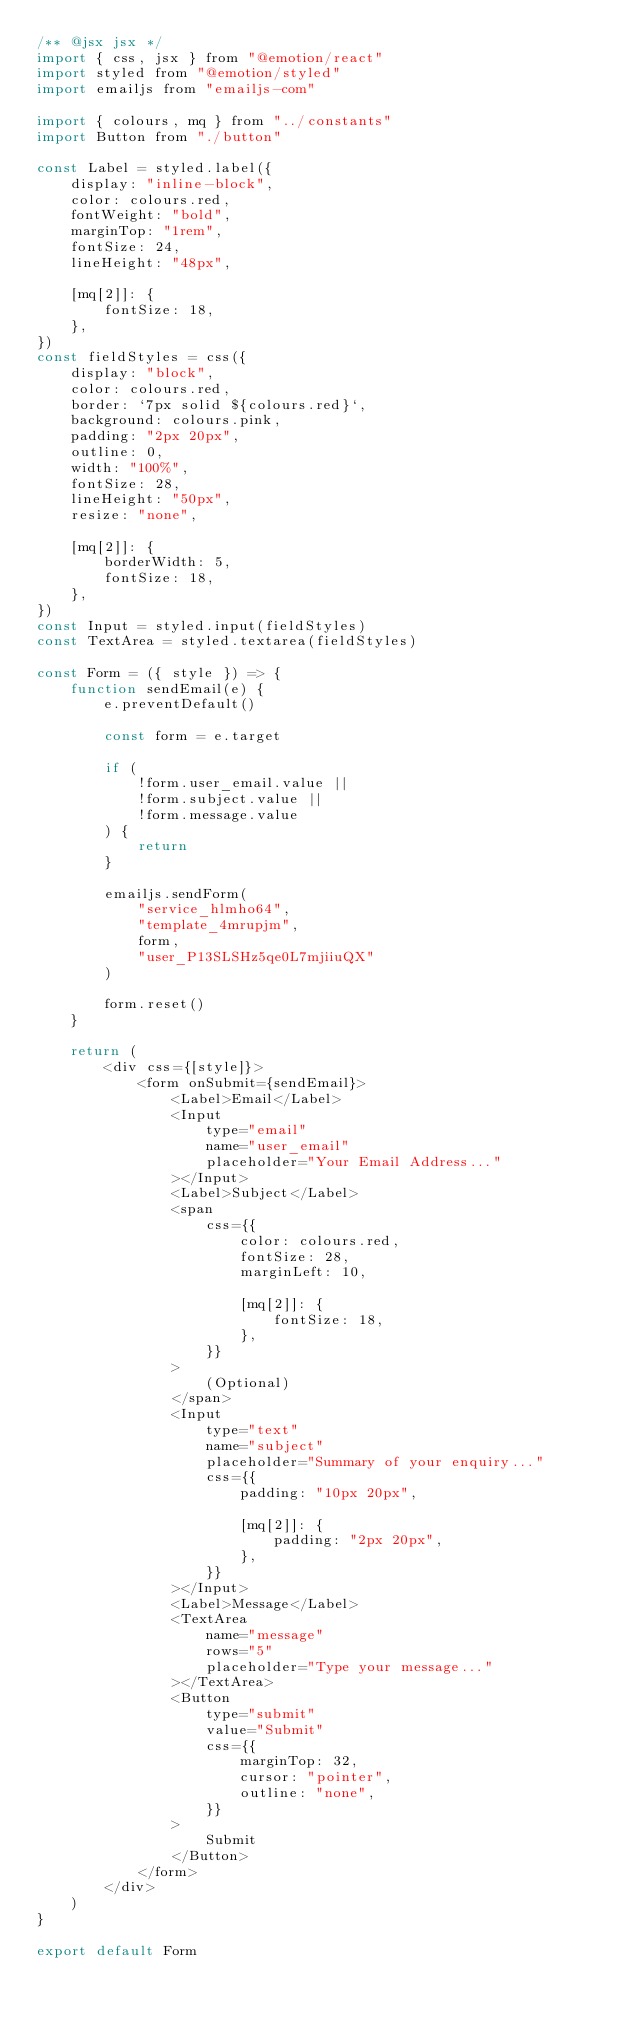<code> <loc_0><loc_0><loc_500><loc_500><_JavaScript_>/** @jsx jsx */
import { css, jsx } from "@emotion/react"
import styled from "@emotion/styled"
import emailjs from "emailjs-com"

import { colours, mq } from "../constants"
import Button from "./button"

const Label = styled.label({
    display: "inline-block",
    color: colours.red,
    fontWeight: "bold",
    marginTop: "1rem",
    fontSize: 24,
    lineHeight: "48px",

    [mq[2]]: {
        fontSize: 18,
    },
})
const fieldStyles = css({
    display: "block",
    color: colours.red,
    border: `7px solid ${colours.red}`,
    background: colours.pink,
    padding: "2px 20px",
    outline: 0,
    width: "100%",
    fontSize: 28,
    lineHeight: "50px",
    resize: "none",

    [mq[2]]: {
        borderWidth: 5,
        fontSize: 18,
    },
})
const Input = styled.input(fieldStyles)
const TextArea = styled.textarea(fieldStyles)

const Form = ({ style }) => {
    function sendEmail(e) {
        e.preventDefault()

        const form = e.target

        if (
            !form.user_email.value ||
            !form.subject.value ||
            !form.message.value
        ) {
            return
        }

        emailjs.sendForm(
            "service_hlmho64",
            "template_4mrupjm",
            form,
            "user_P13SLSHz5qe0L7mjiiuQX"
        )

        form.reset()
    }

    return (
        <div css={[style]}>
            <form onSubmit={sendEmail}>
                <Label>Email</Label>
                <Input
                    type="email"
                    name="user_email"
                    placeholder="Your Email Address..."
                ></Input>
                <Label>Subject</Label>
                <span
                    css={{
                        color: colours.red,
                        fontSize: 28,
                        marginLeft: 10,

                        [mq[2]]: {
                            fontSize: 18,
                        },
                    }}
                >
                    (Optional)
                </span>
                <Input
                    type="text"
                    name="subject"
                    placeholder="Summary of your enquiry..."
                    css={{
                        padding: "10px 20px",

                        [mq[2]]: {
                            padding: "2px 20px",
                        },
                    }}
                ></Input>
                <Label>Message</Label>
                <TextArea
                    name="message"
                    rows="5"
                    placeholder="Type your message..."
                ></TextArea>
                <Button
                    type="submit"
                    value="Submit"
                    css={{
                        marginTop: 32,
                        cursor: "pointer",
                        outline: "none",
                    }}
                >
                    Submit
                </Button>
            </form>
        </div>
    )
}

export default Form
</code> 